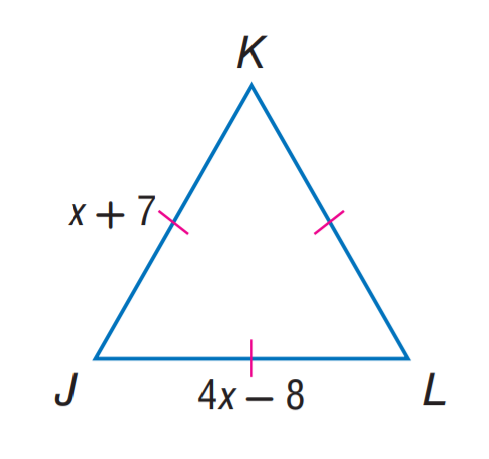Answer the mathemtical geometry problem and directly provide the correct option letter.
Question: Find J K.
Choices: A: 7 B: 8 C: 12 D: 15 C 